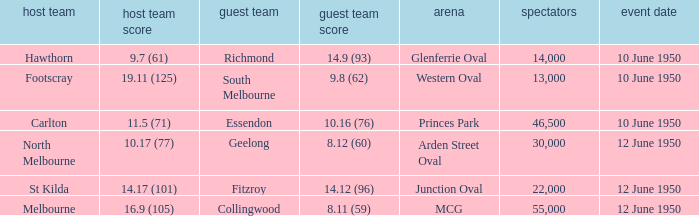What was the crowd when the VFL played MCG? 55000.0. Would you mind parsing the complete table? {'header': ['host team', 'host team score', 'guest team', 'guest team score', 'arena', 'spectators', 'event date'], 'rows': [['Hawthorn', '9.7 (61)', 'Richmond', '14.9 (93)', 'Glenferrie Oval', '14,000', '10 June 1950'], ['Footscray', '19.11 (125)', 'South Melbourne', '9.8 (62)', 'Western Oval', '13,000', '10 June 1950'], ['Carlton', '11.5 (71)', 'Essendon', '10.16 (76)', 'Princes Park', '46,500', '10 June 1950'], ['North Melbourne', '10.17 (77)', 'Geelong', '8.12 (60)', 'Arden Street Oval', '30,000', '12 June 1950'], ['St Kilda', '14.17 (101)', 'Fitzroy', '14.12 (96)', 'Junction Oval', '22,000', '12 June 1950'], ['Melbourne', '16.9 (105)', 'Collingwood', '8.11 (59)', 'MCG', '55,000', '12 June 1950']]} 